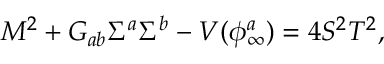<formula> <loc_0><loc_0><loc_500><loc_500>M ^ { 2 } + G _ { a b } \Sigma ^ { a } \Sigma ^ { b } - V ( \phi _ { \infty } ^ { a } ) = 4 S ^ { 2 } T ^ { 2 } ,</formula> 